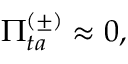<formula> <loc_0><loc_0><loc_500><loc_500>\Pi _ { t a } ^ { ( \pm ) } \approx 0 ,</formula> 